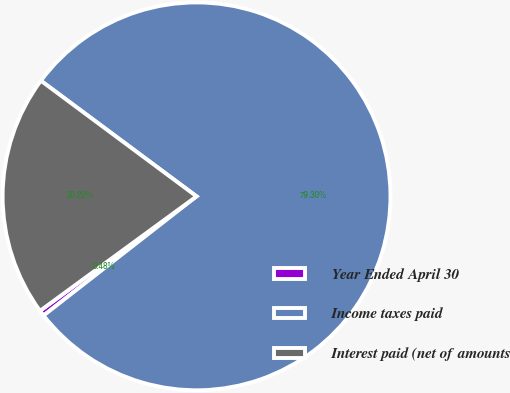<chart> <loc_0><loc_0><loc_500><loc_500><pie_chart><fcel>Year Ended April 30<fcel>Income taxes paid<fcel>Interest paid (net of amounts<nl><fcel>0.48%<fcel>79.3%<fcel>20.22%<nl></chart> 